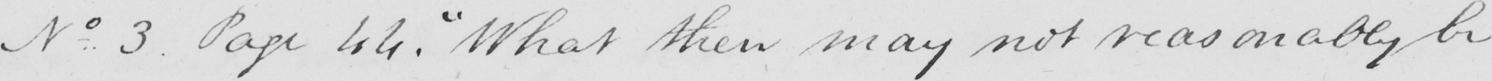Can you read and transcribe this handwriting? No. . 3 . Page 44 .  " What then may not reasonably be 